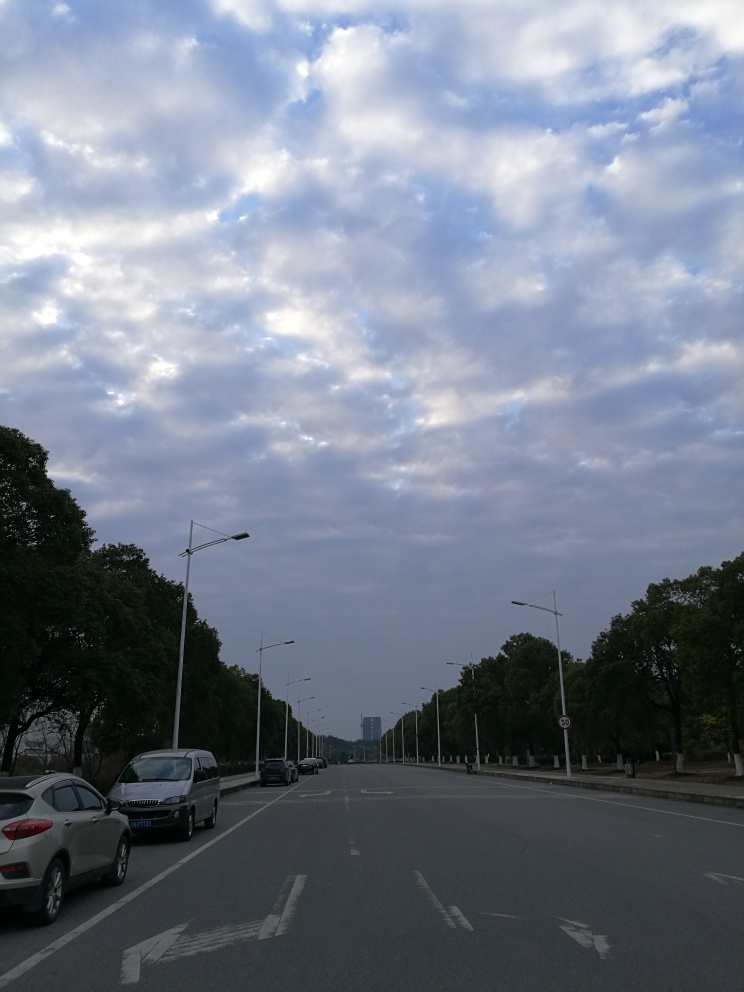Can you tell anything about the location or the region the photo might depict? While there's no direct indication of a specific location, the style of the lampposts, the road markings, and the cars driving on the right suggest it could be somewhere in Europe or a region with similar traffic rules and infrastructure. The broad street flanked by trees and the building in the distant background with a modern architectural style give an urban yet spacious feel to the location. What can we infer about the traffic and transportation habits from this image? The lanes are clearly marked, and there's a variety of vehicles indicating the use of personal cars for transportation. The street isn't crowded, which might suggest the photo was taken on a non-peak hour or that it's in a less congested urban area. Additionally, the presence of speed limit signs demonstrates a regulated road system. 